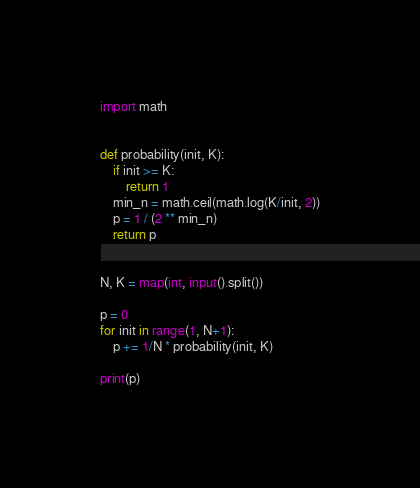Convert code to text. <code><loc_0><loc_0><loc_500><loc_500><_Python_>import math


def probability(init, K):
    if init >= K:
        return 1
    min_n = math.ceil(math.log(K/init, 2))
    p = 1 / (2 ** min_n)
    return p


N, K = map(int, input().split())

p = 0
for init in range(1, N+1):
    p += 1/N * probability(init, K)

print(p)</code> 